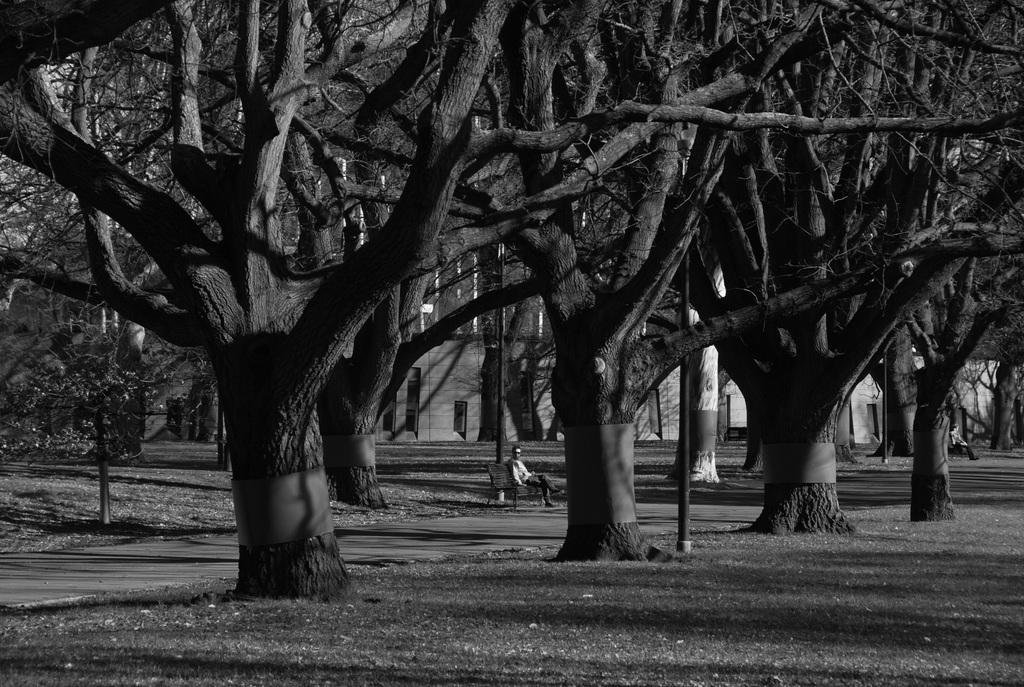What type of vegetation can be seen in the image? There are trees in the image. What is the man on the bench doing in the image? There is a man seated on a bench in the image. What type of structures are visible in the image? There are buildings visible in the image. How many men are seated in the image? There are two men seated in the image. What is the ground covered with in the image? Grass is present on the ground in the image. What type of powder can be seen falling from the sky in the image? There is no powder falling from the sky in the image; it only shows trees, a man on a bench, buildings, another man seated, and grass on the ground. What type of writing can be seen on the buildings in the image? There is no writing visible on the buildings in the image. 